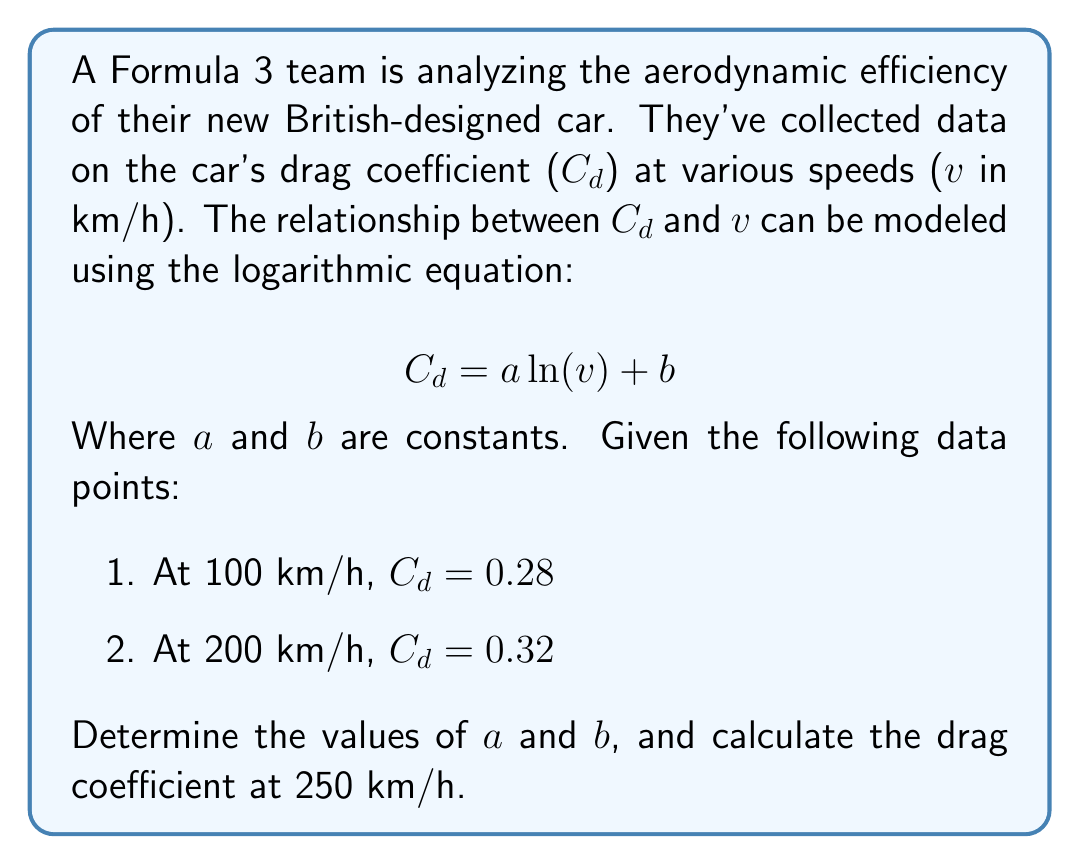Give your solution to this math problem. Let's solve this step-by-step:

1) We have two equations based on the given data:
   $$ 0.28 = a \ln(100) + b $$
   $$ 0.32 = a \ln(200) + b $$

2) Subtract the first equation from the second:
   $$ 0.32 - 0.28 = a(\ln(200) - \ln(100)) $$
   $$ 0.04 = a(\ln(2)) $$

3) Solve for a:
   $$ a = \frac{0.04}{\ln(2)} \approx 0.0577 $$

4) Substitute this value of a into either of the original equations to solve for b:
   $$ 0.28 = 0.0577 \ln(100) + b $$
   $$ b = 0.28 - 0.0577 \ln(100) \approx 0.0140 $$

5) Now we have our complete equation:
   $$ Cd = 0.0577 \ln(v) + 0.0140 $$

6) To find Cd at 250 km/h, simply substitute v = 250:
   $$ Cd = 0.0577 \ln(250) + 0.0140 \approx 0.3372 $$
Answer: a ≈ 0.0577, b ≈ 0.0140, Cd(250 km/h) ≈ 0.3372 